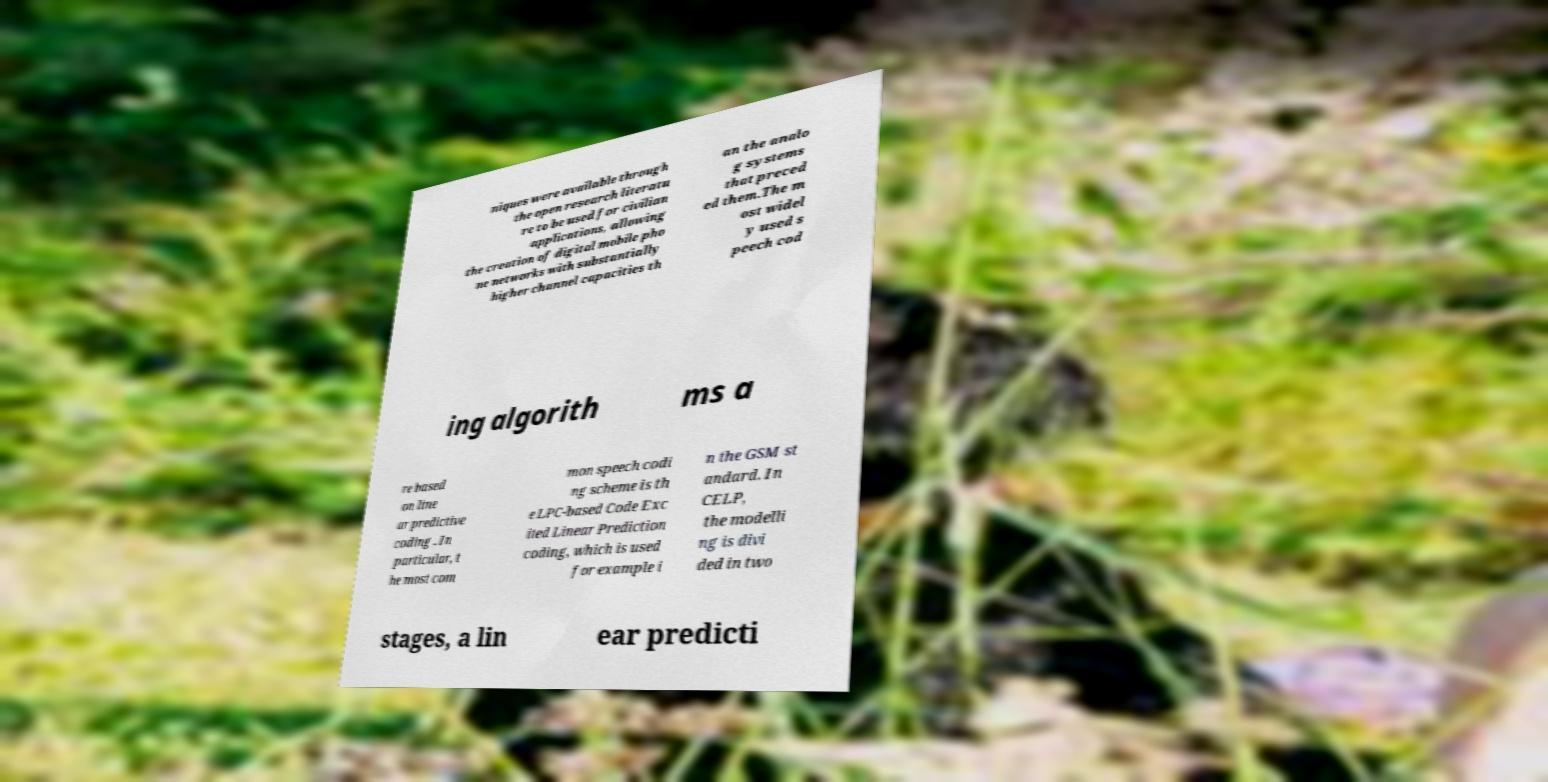Please identify and transcribe the text found in this image. niques were available through the open research literatu re to be used for civilian applications, allowing the creation of digital mobile pho ne networks with substantially higher channel capacities th an the analo g systems that preced ed them.The m ost widel y used s peech cod ing algorith ms a re based on line ar predictive coding . In particular, t he most com mon speech codi ng scheme is th e LPC-based Code Exc ited Linear Prediction coding, which is used for example i n the GSM st andard. In CELP, the modelli ng is divi ded in two stages, a lin ear predicti 